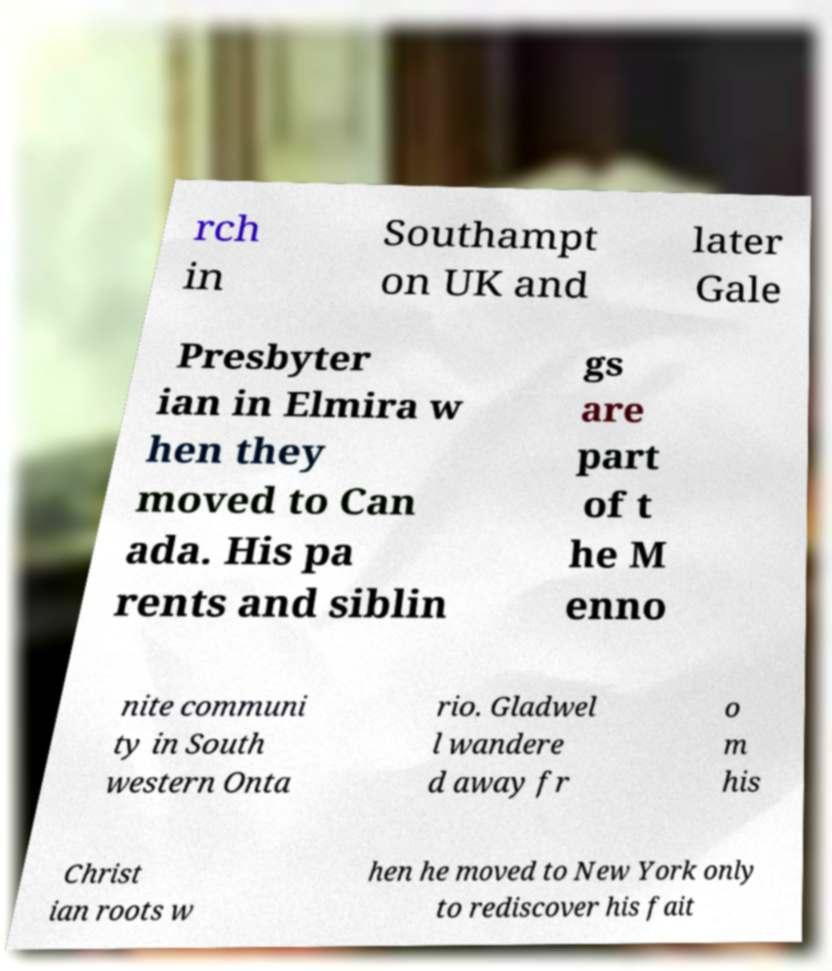Please read and relay the text visible in this image. What does it say? rch in Southampt on UK and later Gale Presbyter ian in Elmira w hen they moved to Can ada. His pa rents and siblin gs are part of t he M enno nite communi ty in South western Onta rio. Gladwel l wandere d away fr o m his Christ ian roots w hen he moved to New York only to rediscover his fait 